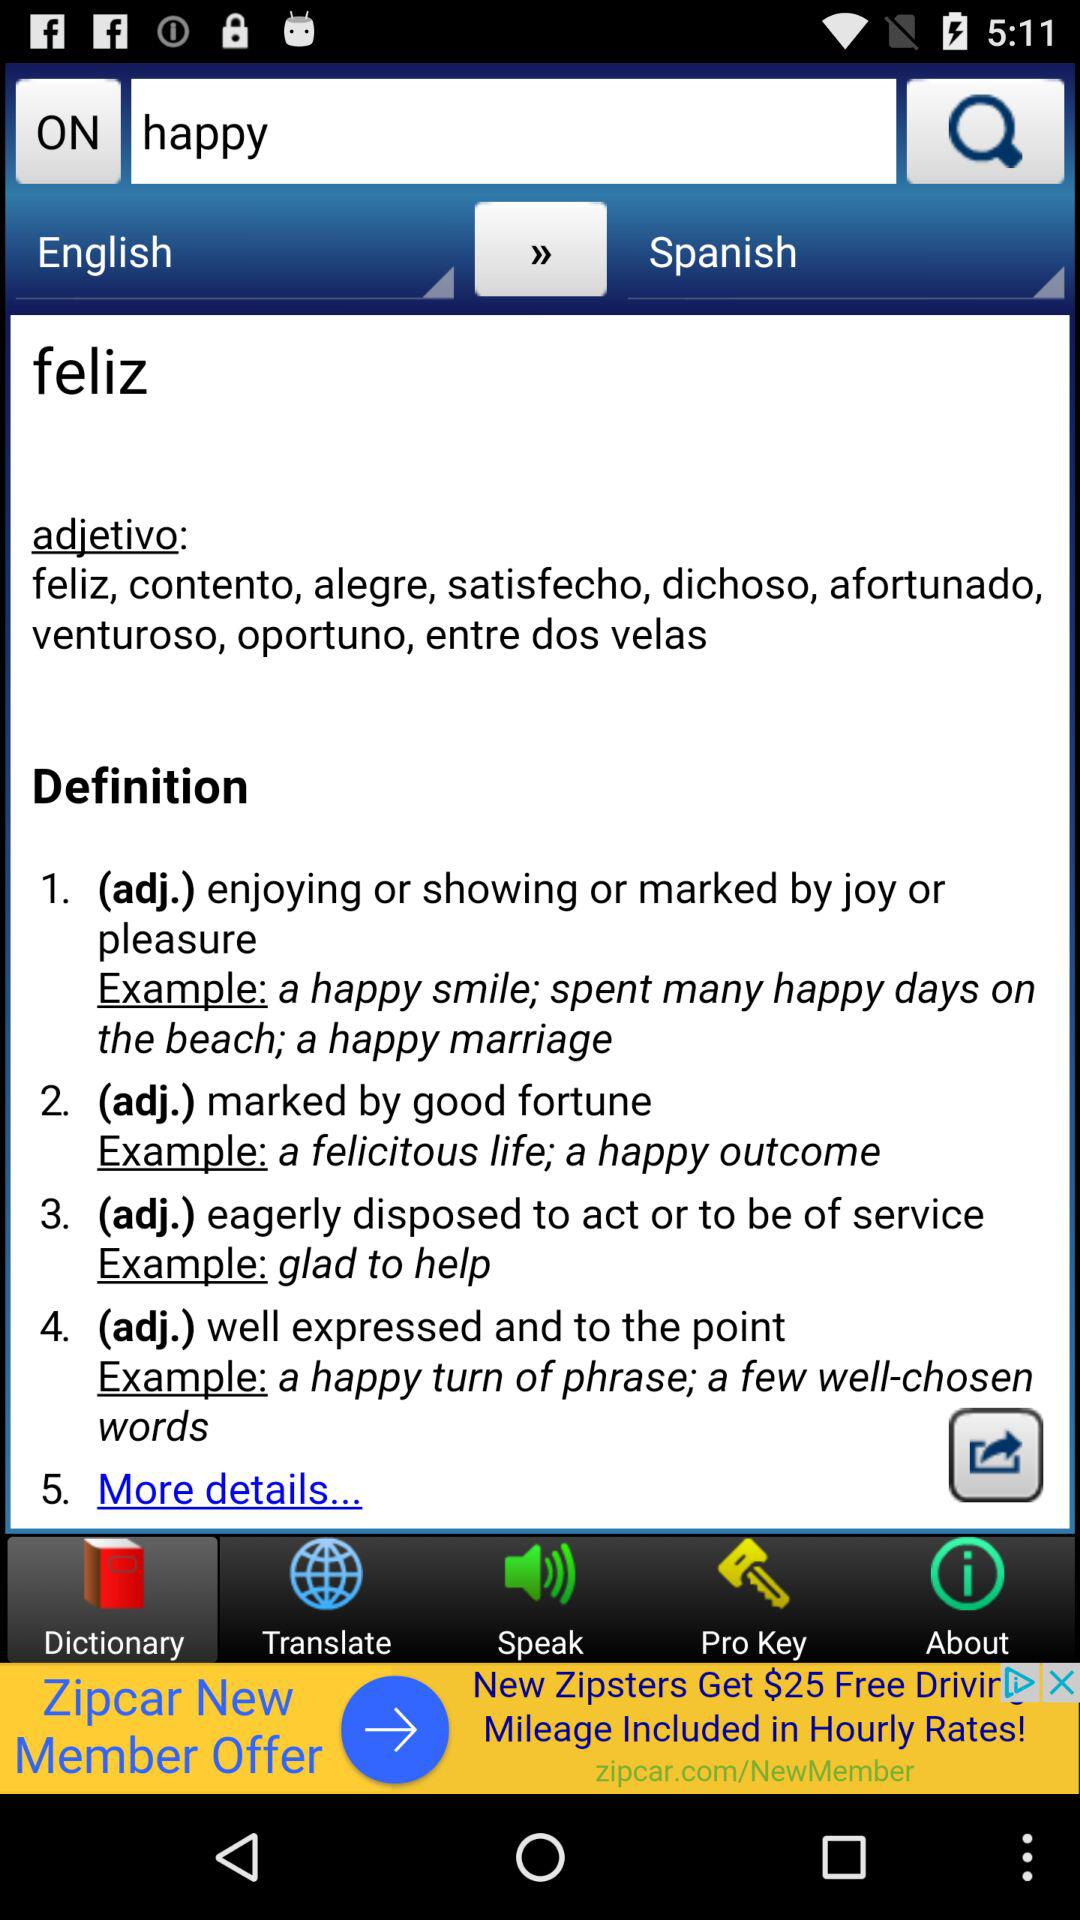What is the word typed in the search bar? The word typed in the search bar is "happy". 